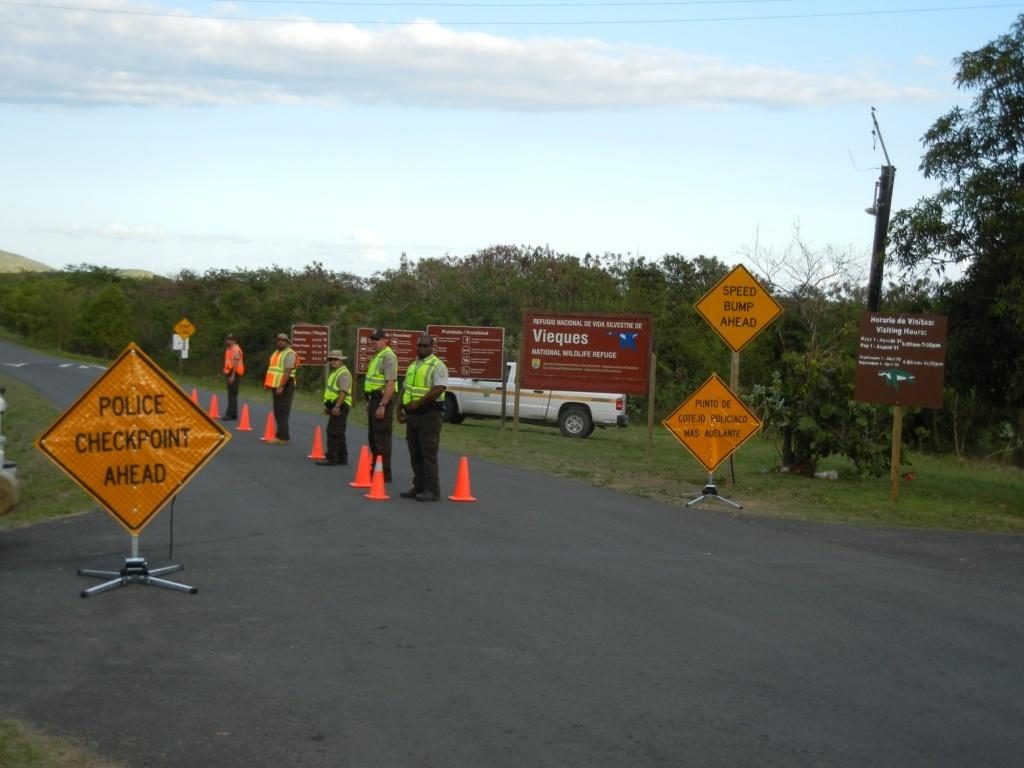<image>
Present a compact description of the photo's key features. Several men in safety vests run a police checkpoint. 